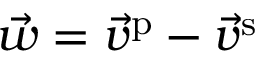<formula> <loc_0><loc_0><loc_500><loc_500>\vec { w } = \vec { v } ^ { p } - \vec { v } ^ { s }</formula> 